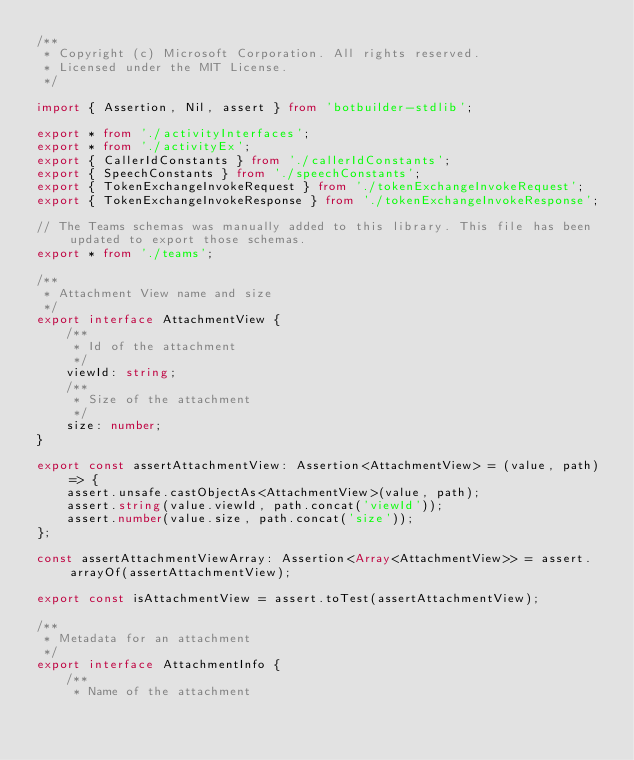<code> <loc_0><loc_0><loc_500><loc_500><_TypeScript_>/**
 * Copyright (c) Microsoft Corporation. All rights reserved.
 * Licensed under the MIT License.
 */

import { Assertion, Nil, assert } from 'botbuilder-stdlib';

export * from './activityInterfaces';
export * from './activityEx';
export { CallerIdConstants } from './callerIdConstants';
export { SpeechConstants } from './speechConstants';
export { TokenExchangeInvokeRequest } from './tokenExchangeInvokeRequest';
export { TokenExchangeInvokeResponse } from './tokenExchangeInvokeResponse';

// The Teams schemas was manually added to this library. This file has been updated to export those schemas.
export * from './teams';

/**
 * Attachment View name and size
 */
export interface AttachmentView {
    /**
     * Id of the attachment
     */
    viewId: string;
    /**
     * Size of the attachment
     */
    size: number;
}

export const assertAttachmentView: Assertion<AttachmentView> = (value, path) => {
    assert.unsafe.castObjectAs<AttachmentView>(value, path);
    assert.string(value.viewId, path.concat('viewId'));
    assert.number(value.size, path.concat('size'));
};

const assertAttachmentViewArray: Assertion<Array<AttachmentView>> = assert.arrayOf(assertAttachmentView);

export const isAttachmentView = assert.toTest(assertAttachmentView);

/**
 * Metadata for an attachment
 */
export interface AttachmentInfo {
    /**
     * Name of the attachment</code> 